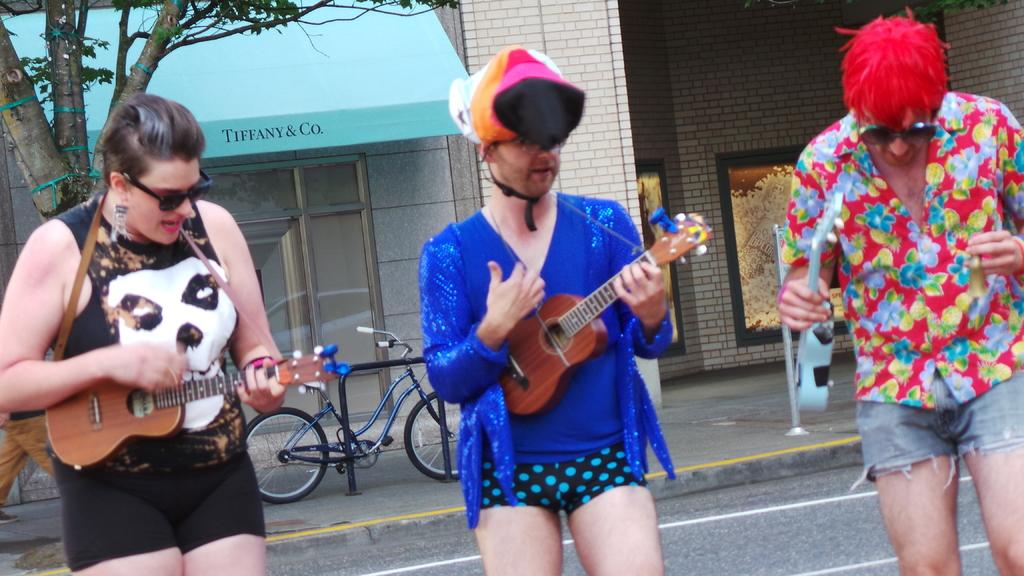Who is present in the image? There is a woman and two men in the image. What are the men doing in the image? The men are playing a guitar. What can be seen in the background of the image? There is a bicycle and a tree in the background of the image. How many fans are visible in the image? There are no fans present in the image. What type of trains can be seen in the image? There are no trains present in the image. 